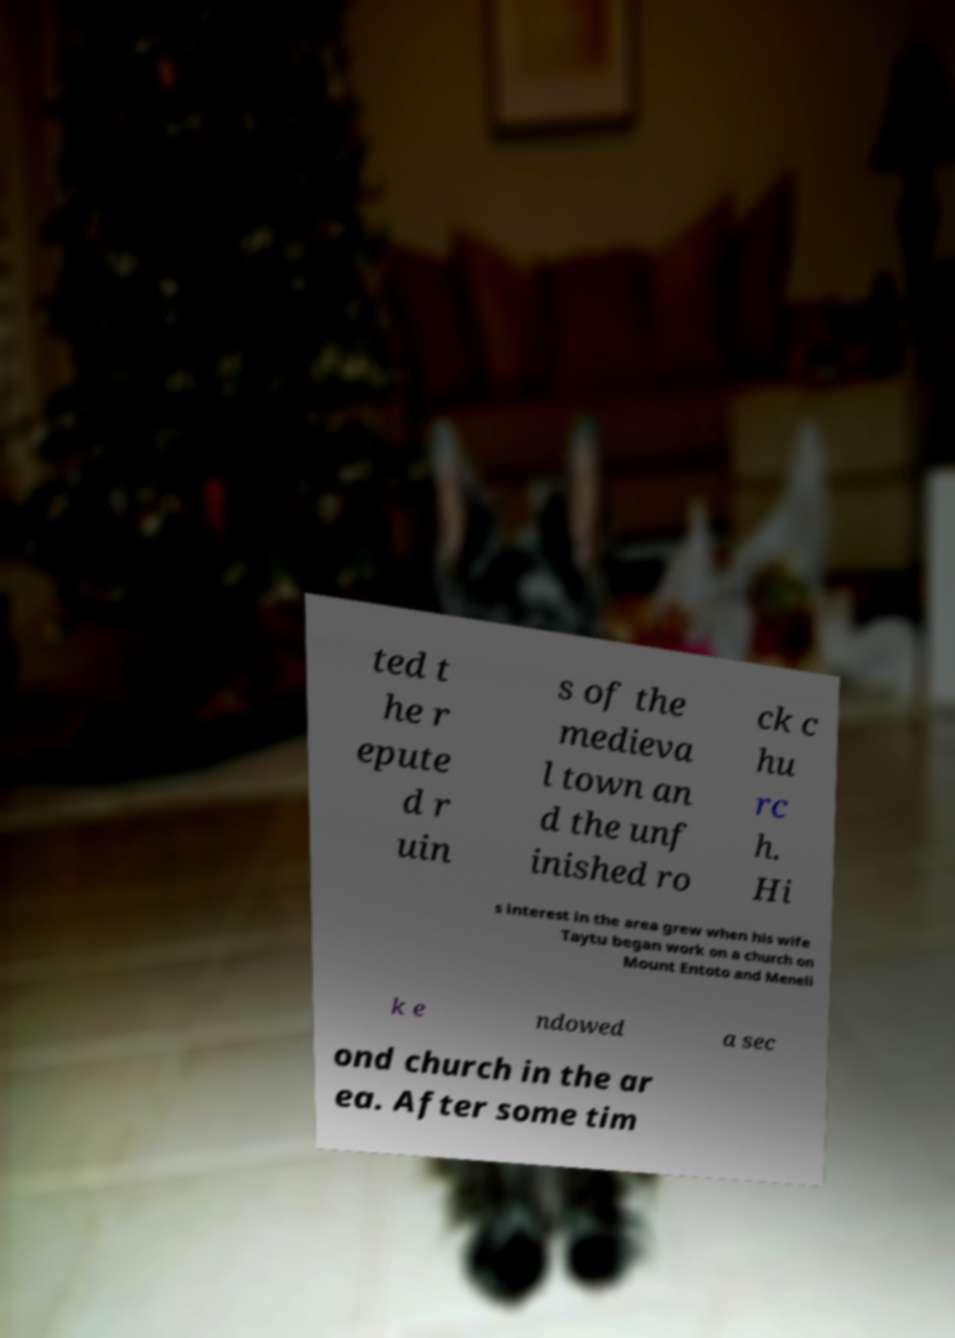Could you extract and type out the text from this image? ted t he r epute d r uin s of the medieva l town an d the unf inished ro ck c hu rc h. Hi s interest in the area grew when his wife Taytu began work on a church on Mount Entoto and Meneli k e ndowed a sec ond church in the ar ea. After some tim 